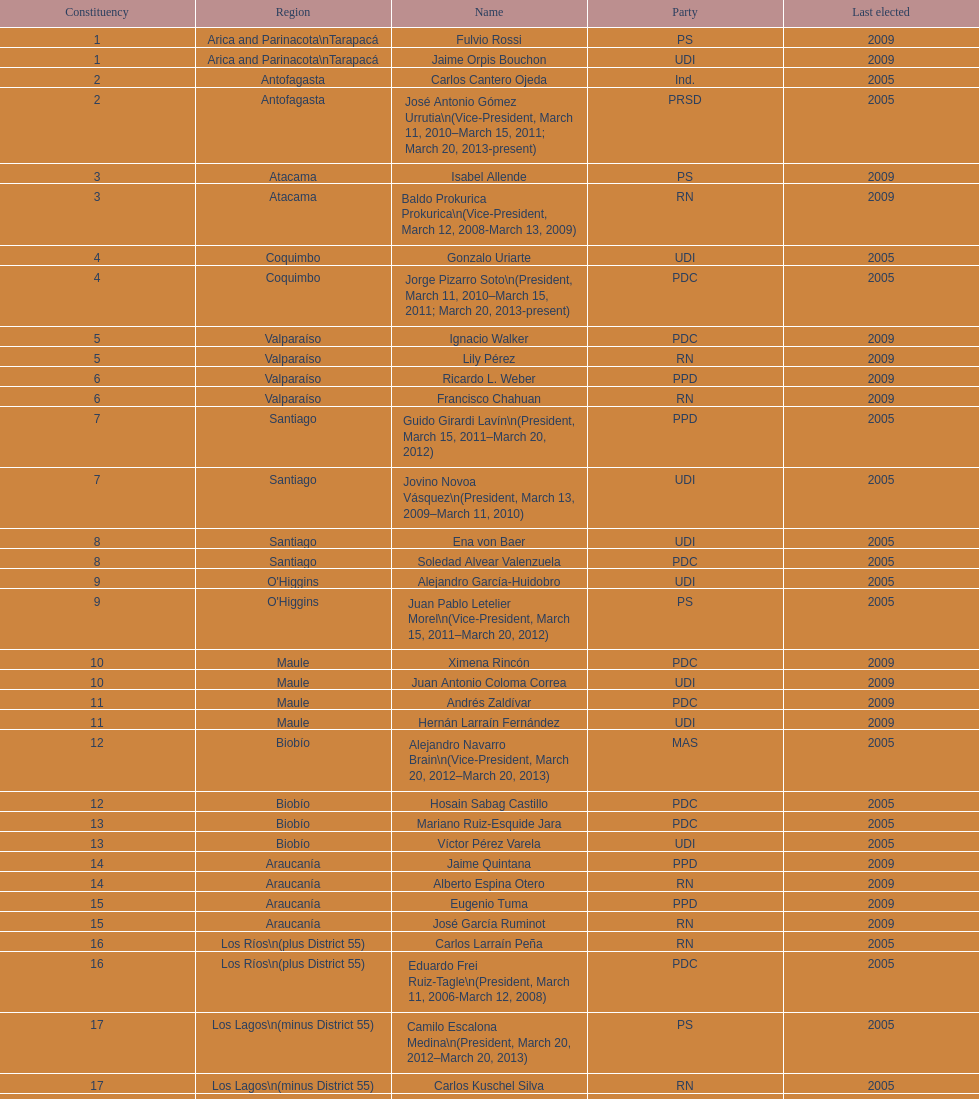What is the first name on the table? Fulvio Rossi. 